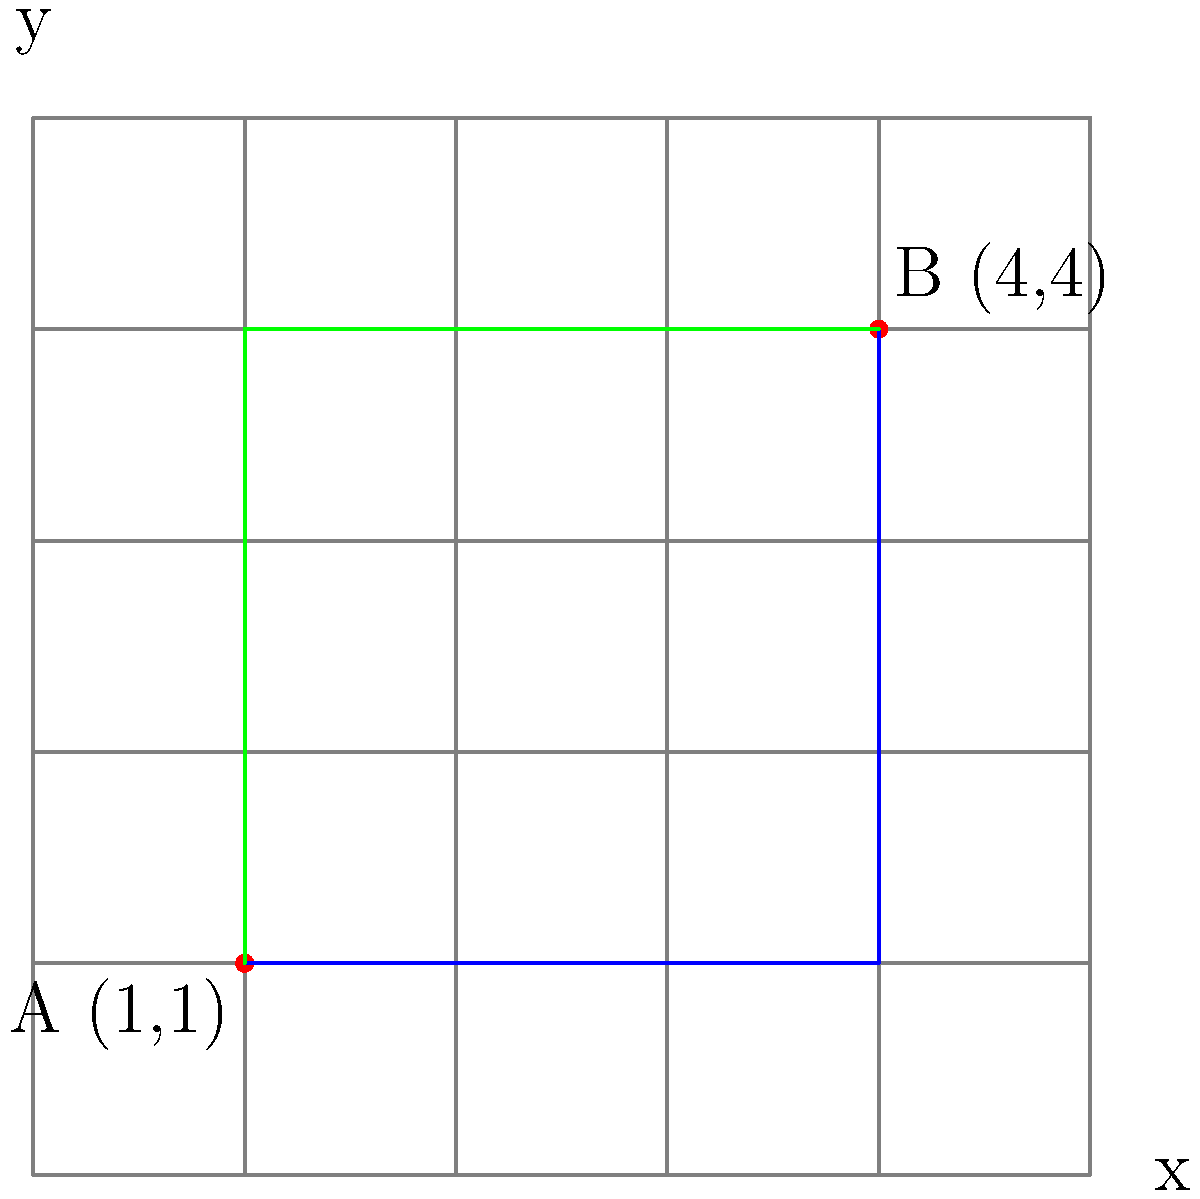As a firefighter, you need to calculate the shortest route between two points on a city grid to reach an emergency location quickly. Given two points A(1,1) and B(4,4) on a city grid where each unit represents one block, what is the shortest distance between these points? Assume you can only move along the grid lines (i.e., horizontally or vertically). To find the shortest distance between two points on a city grid where movement is restricted to horizontal and vertical directions, we need to calculate the Manhattan distance (also known as the taxicab distance or L1 norm).

Step 1: Identify the coordinates of the two points.
Point A: (1,1)
Point B: (4,4)

Step 2: Calculate the horizontal distance.
Horizontal distance = |x2 - x1| = |4 - 1| = 3 blocks

Step 3: Calculate the vertical distance.
Vertical distance = |y2 - y1| = |4 - 1| = 3 blocks

Step 4: Sum the horizontal and vertical distances.
Shortest distance = Horizontal distance + Vertical distance
                  = 3 + 3 = 6 blocks

The blue and green paths in the diagram both represent shortest routes, as they both cover a total of 6 blocks.

This method ensures the quickest response time by providing the minimum number of blocks that need to be traversed to reach the emergency location.
Answer: 6 blocks 